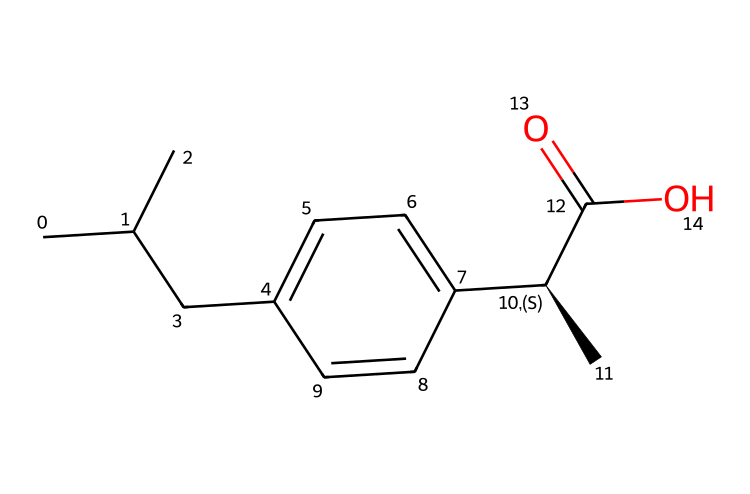What is the molecular formula of ibuprofen? By analyzing the SMILES representation, we can count the number of each atom type. There are 13 carbons (C), 18 hydrogens (H), and 2 oxygens (O), leading to the molecular formula C13H18O2.
Answer: C13H18O2 How many chiral centers are present in ibuprofen? The SMILES notation shows a specific stereocenter marked as [C@H], indicating one chiral center in the structure of ibuprofen.
Answer: 1 What type of functional group is present at the end of the ibuprofen structure? The SMILES representation contains “C(=O)O”, which indicates the presence of a carboxylic acid functional group characterized by a carbon double-bonded to oxygen and single-bonded to a hydroxyl group (OH).
Answer: carboxylic acid What is the relationship between the two enantiomers of ibuprofen? The presence of one chiral center means ibuprofen has two enantiomers, which are non-superimposable mirror images of each other, differing at the chiral carbon atom.
Answer: enantiomers What is the effect of chirality on the pharmacological activity of ibuprofen? The chiral center affects how ibuprofen interacts with biological targets; typically, one enantiomer may be more effective or have fewer side effects than the other, showing that chirality plays a crucial role in its activity.
Answer: pharmacological activity What is the common use of ibuprofen? Ibuprofen is widely recognized as a non-steroidal anti-inflammatory drug (NSAID), primarily used for pain relief, anti-inflammatory effects, and reducing fever.
Answer: pain reliever 